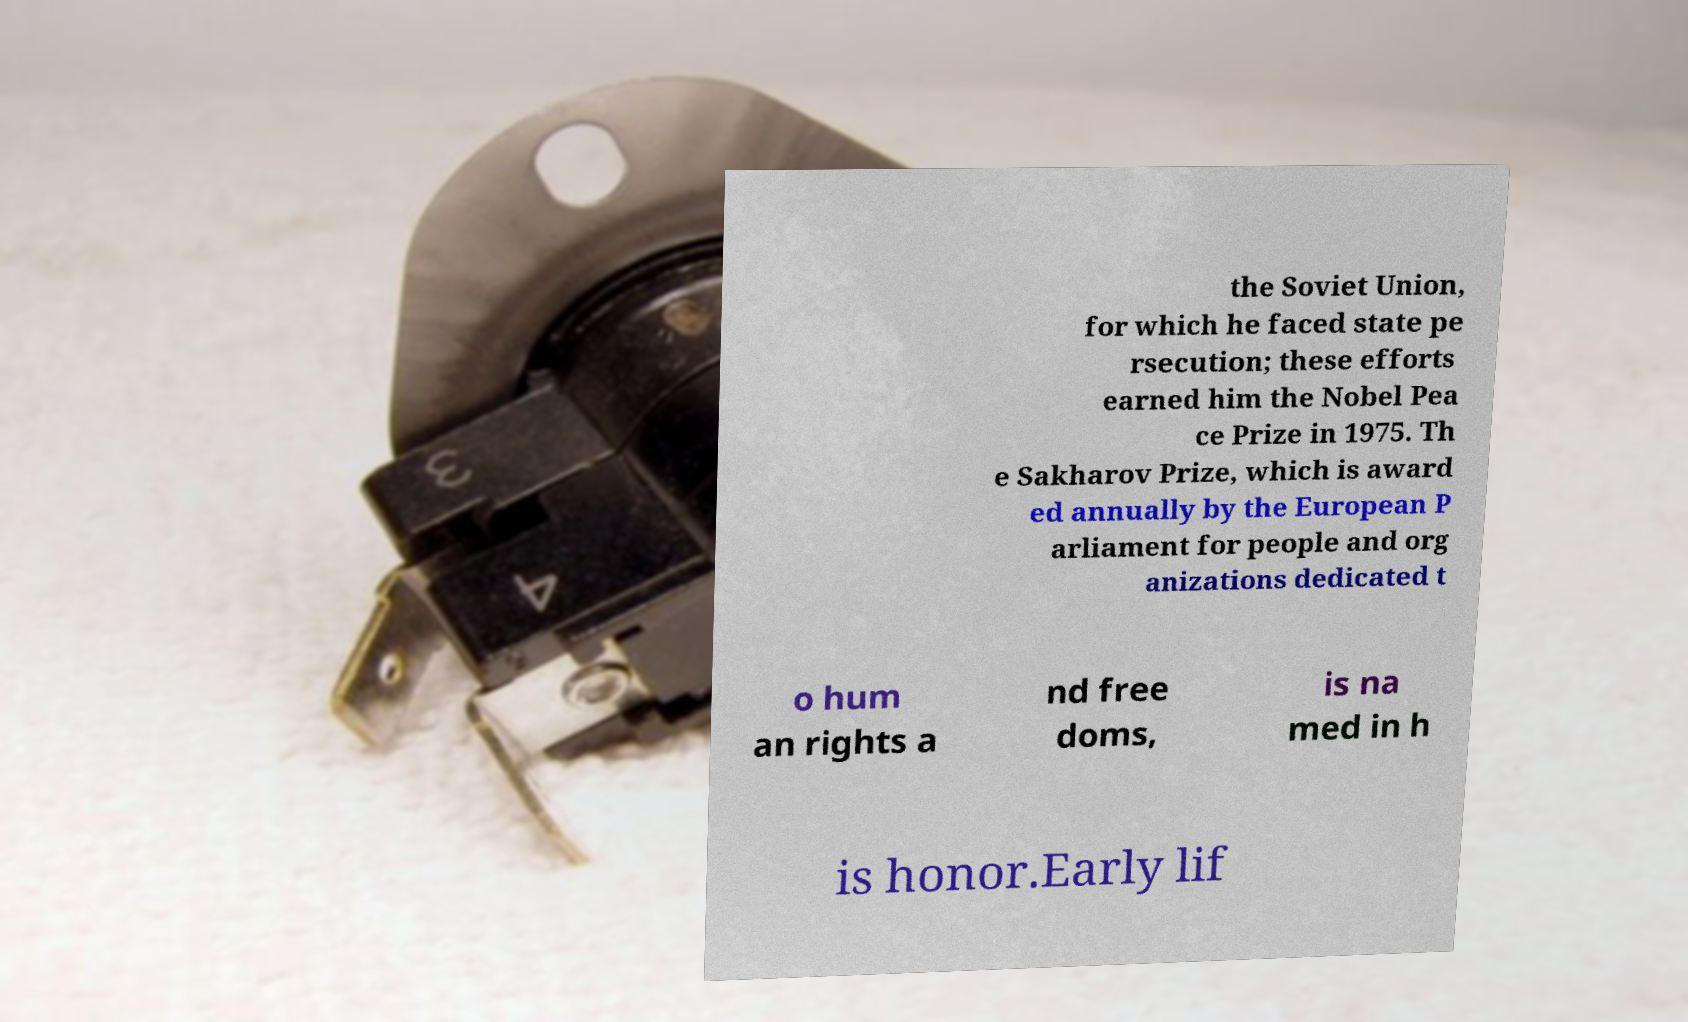There's text embedded in this image that I need extracted. Can you transcribe it verbatim? the Soviet Union, for which he faced state pe rsecution; these efforts earned him the Nobel Pea ce Prize in 1975. Th e Sakharov Prize, which is award ed annually by the European P arliament for people and org anizations dedicated t o hum an rights a nd free doms, is na med in h is honor.Early lif 